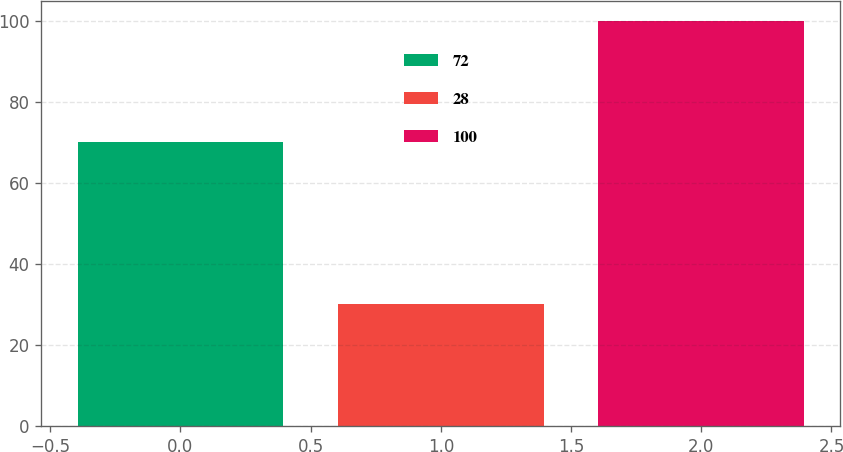Convert chart. <chart><loc_0><loc_0><loc_500><loc_500><bar_chart><fcel>72<fcel>28<fcel>100<nl><fcel>70<fcel>30<fcel>100<nl></chart> 